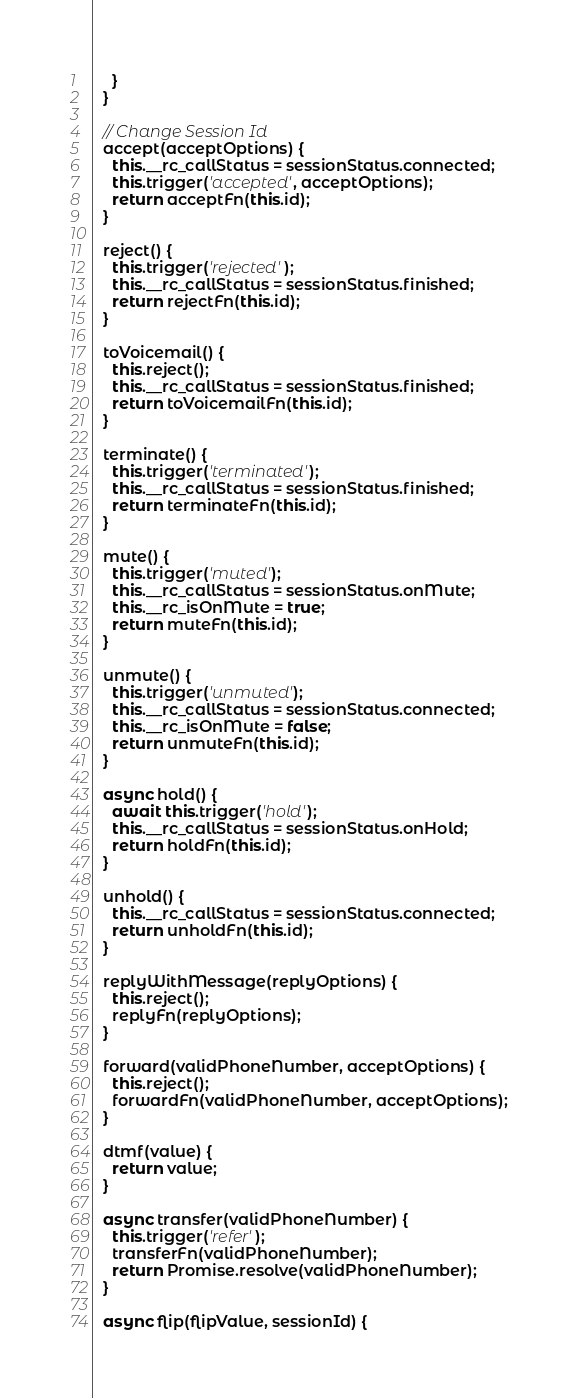<code> <loc_0><loc_0><loc_500><loc_500><_JavaScript_>    }
  }

  // Change Session Id
  accept(acceptOptions) {
    this.__rc_callStatus = sessionStatus.connected;
    this.trigger('accepted', acceptOptions);
    return acceptFn(this.id);
  }

  reject() {
    this.trigger('rejected');
    this.__rc_callStatus = sessionStatus.finished;
    return rejectFn(this.id);
  }

  toVoicemail() {
    this.reject();
    this.__rc_callStatus = sessionStatus.finished;
    return toVoicemailFn(this.id);
  }

  terminate() {
    this.trigger('terminated');
    this.__rc_callStatus = sessionStatus.finished;
    return terminateFn(this.id);
  }

  mute() {
    this.trigger('muted');
    this.__rc_callStatus = sessionStatus.onMute;
    this.__rc_isOnMute = true;
    return muteFn(this.id);
  }

  unmute() {
    this.trigger('unmuted');
    this.__rc_callStatus = sessionStatus.connected;
    this.__rc_isOnMute = false;
    return unmuteFn(this.id);
  }

  async hold() {
    await this.trigger('hold');
    this.__rc_callStatus = sessionStatus.onHold;
    return holdFn(this.id);
  }

  unhold() {
    this.__rc_callStatus = sessionStatus.connected;
    return unholdFn(this.id);
  }

  replyWithMessage(replyOptions) {
    this.reject();
    replyFn(replyOptions);
  }

  forward(validPhoneNumber, acceptOptions) {
    this.reject();
    forwardFn(validPhoneNumber, acceptOptions);
  }

  dtmf(value) {
    return value;
  }

  async transfer(validPhoneNumber) {
    this.trigger('refer');
    transferFn(validPhoneNumber);
    return Promise.resolve(validPhoneNumber);
  }

  async flip(flipValue, sessionId) {</code> 